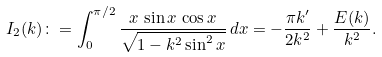Convert formula to latex. <formula><loc_0><loc_0><loc_500><loc_500>I _ { 2 } ( k ) \colon = \int _ { 0 } ^ { \pi / 2 } \frac { x \, \sin x \, \cos x } { \sqrt { 1 - k ^ { 2 } \sin ^ { 2 } x } } \, d x = - \frac { \pi k ^ { \prime } } { 2 k ^ { 2 } } + \frac { E ( k ) } { k ^ { 2 } } .</formula> 